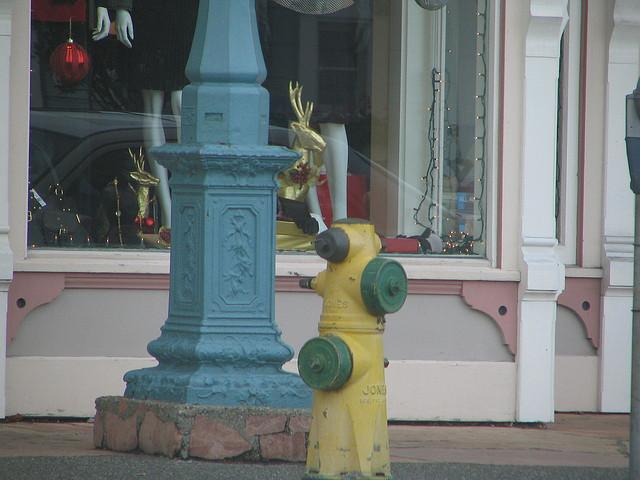What color skirts are the mannequins wearing?
Concise answer only. Black. What decorations are in the window in the background?
Be succinct. Christmas. What color are the caps on the fire hydrant?
Give a very brief answer. Green. 